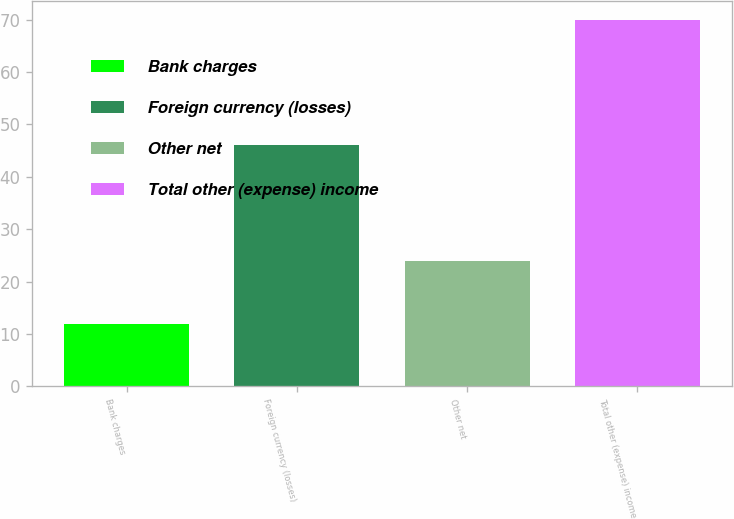Convert chart to OTSL. <chart><loc_0><loc_0><loc_500><loc_500><bar_chart><fcel>Bank charges<fcel>Foreign currency (losses)<fcel>Other net<fcel>Total other (expense) income<nl><fcel>12<fcel>46<fcel>24<fcel>70<nl></chart> 